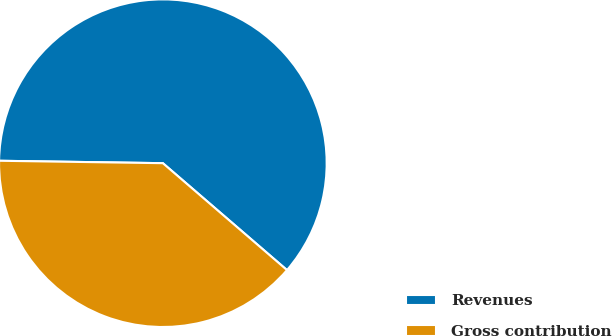Convert chart to OTSL. <chart><loc_0><loc_0><loc_500><loc_500><pie_chart><fcel>Revenues<fcel>Gross contribution<nl><fcel>61.08%<fcel>38.92%<nl></chart> 